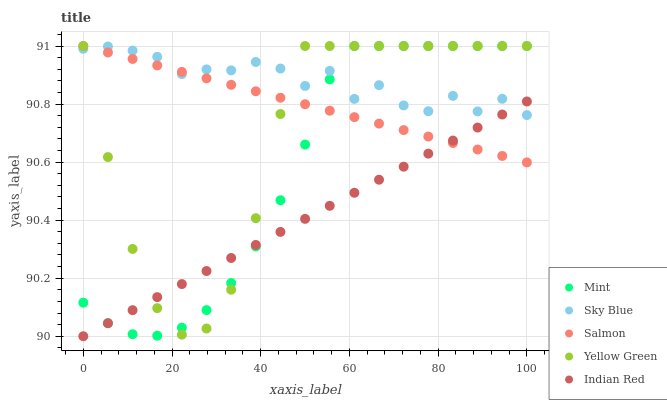Does Indian Red have the minimum area under the curve?
Answer yes or no. Yes. Does Sky Blue have the maximum area under the curve?
Answer yes or no. Yes. Does Mint have the minimum area under the curve?
Answer yes or no. No. Does Mint have the maximum area under the curve?
Answer yes or no. No. Is Salmon the smoothest?
Answer yes or no. Yes. Is Sky Blue the roughest?
Answer yes or no. Yes. Is Mint the smoothest?
Answer yes or no. No. Is Mint the roughest?
Answer yes or no. No. Does Indian Red have the lowest value?
Answer yes or no. Yes. Does Mint have the lowest value?
Answer yes or no. No. Does Salmon have the highest value?
Answer yes or no. Yes. Does Indian Red have the highest value?
Answer yes or no. No. Does Sky Blue intersect Salmon?
Answer yes or no. Yes. Is Sky Blue less than Salmon?
Answer yes or no. No. Is Sky Blue greater than Salmon?
Answer yes or no. No. 